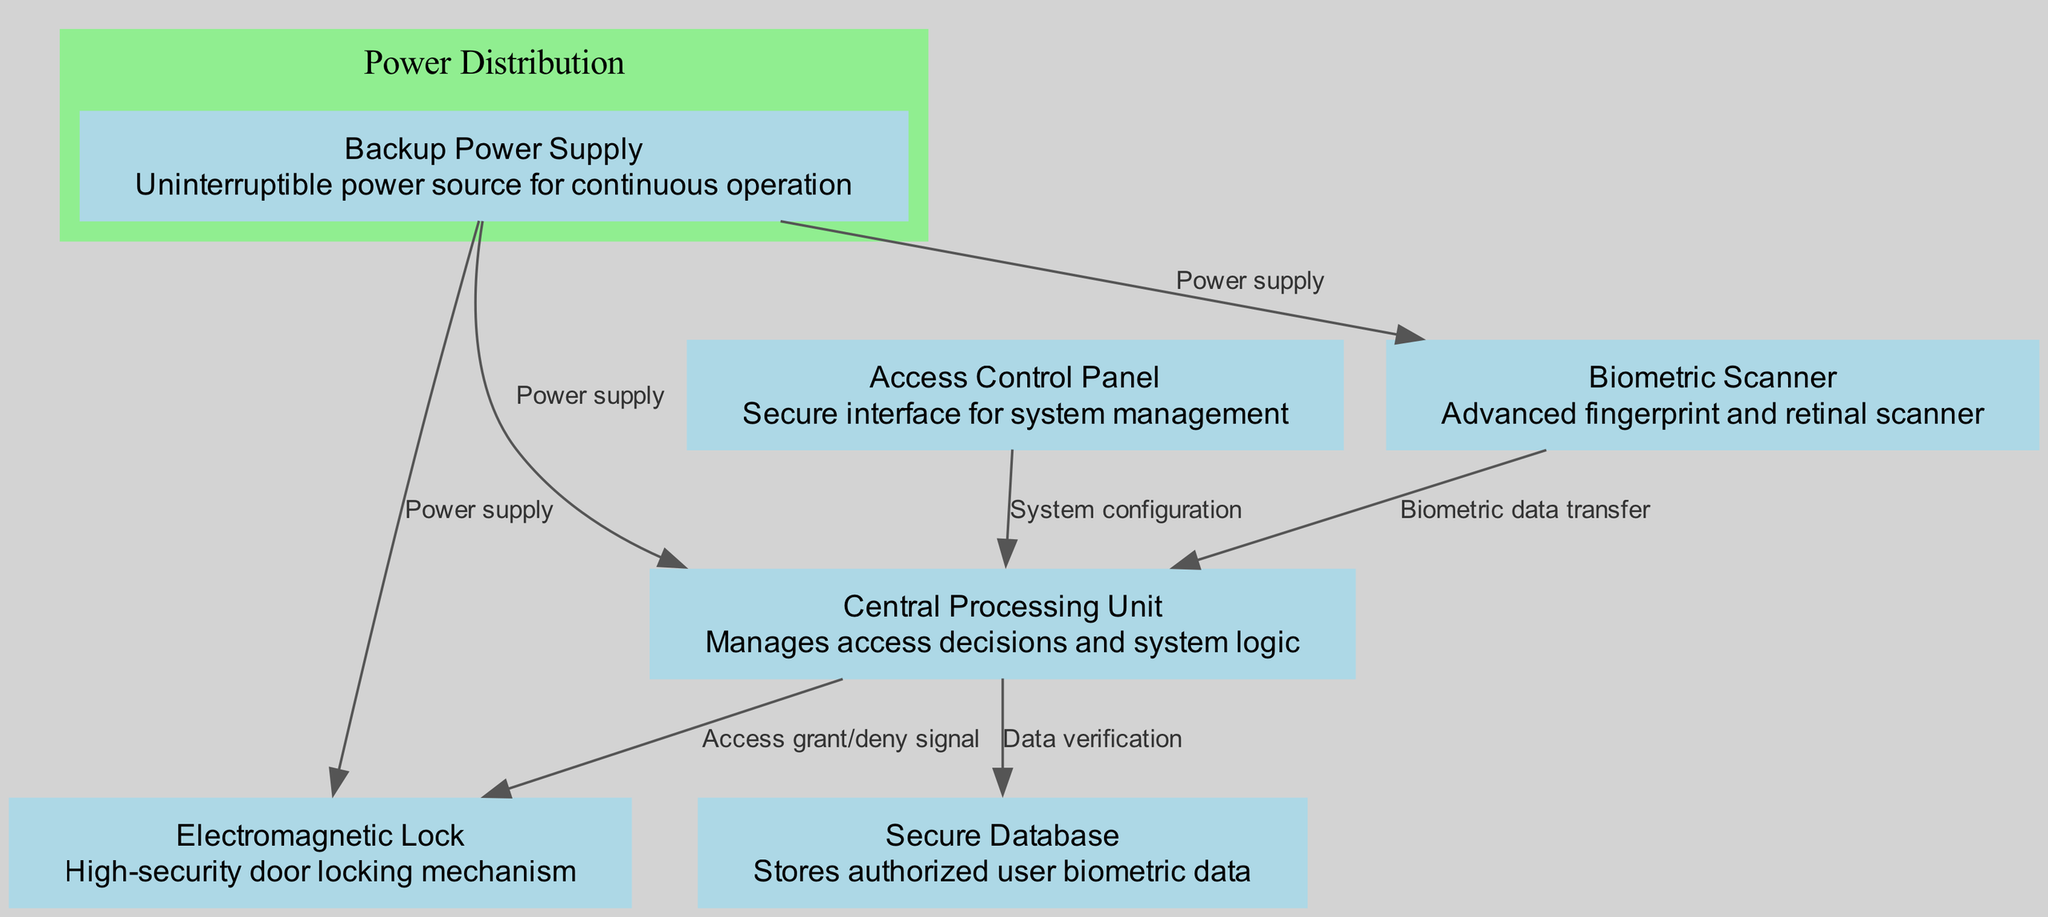What is the main function of the Biometric Scanner? The main function of the Biometric Scanner, as indicated in the diagram, is to perform advanced fingerprint and retinal scanning. This node is identified as node 1 with that description.
Answer: Advanced fingerprint and retinal scanner How many nodes are present in the diagram? The diagram illustrates a total of six nodes: Biometric Scanner, Access Control Panel, Electromagnetic Lock, Backup Power Supply, Central Processing Unit, and Secure Database. These are specifically identified in the node list.
Answer: 6 What does the Access Control Panel connect to? The Access Control Panel (node 2) connects to the Central Processing Unit (node 5) for system configuration, which is indicated by a directed edge labeled "System configuration."
Answer: Central Processing Unit Which component receives power supply from the Backup Power Supply? The Backup Power Supply provides power supply to three components: Biometric Scanner, Electromagnetic Lock, and Central Processing Unit, as shown in the edges of the diagram.
Answer: Biometric Scanner, Electromagnetic Lock, Central Processing Unit How does the Central Processing Unit interact with the Secure Database? The Central Processing Unit (node 5) verifies the data against that stored in the Secure Database (node 6) through a directed edge labeled "Data verification," indicating a connection and interaction between these two components.
Answer: Data verification What is the relationship between the Biometric Scanner and the Central Processing Unit? The Biometric Scanner (node 1) transfers biometric data to the Central Processing Unit (node 5), as described by the edge labeled "Biometric data transfer." This signifies a direct flow of data from the scanner to the processor for decision-making.
Answer: Biometric data transfer Which node is responsible for managing access decisions in the system? The Central Processing Unit (node 5) is explicitly designated as the component that manages access decisions and system logic, as noted in its description.
Answer: Central Processing Unit What are the components contained within the Power Distribution cluster? The Power Distribution cluster includes the Backup Power Supply (node 4), which connects to the Biometric Scanner, Electromagnetic Lock, and Central Processing Unit, emphasizing its role in ensuring power continuity for these components.
Answer: Backup Power Supply Which component receives the access grant or deny signal? The Electromagnetic Lock (node 3) receives the access grant or deny signal from the Central Processing Unit (node 5) through the directed edge labeled "Access grant/deny signal," indicating its role in the physical security mechanism.
Answer: Electromagnetic Lock 